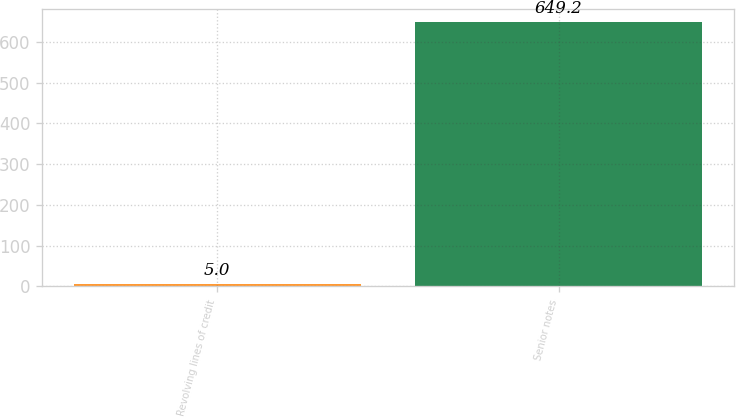<chart> <loc_0><loc_0><loc_500><loc_500><bar_chart><fcel>Revolving lines of credit<fcel>Senior notes<nl><fcel>5<fcel>649.2<nl></chart> 